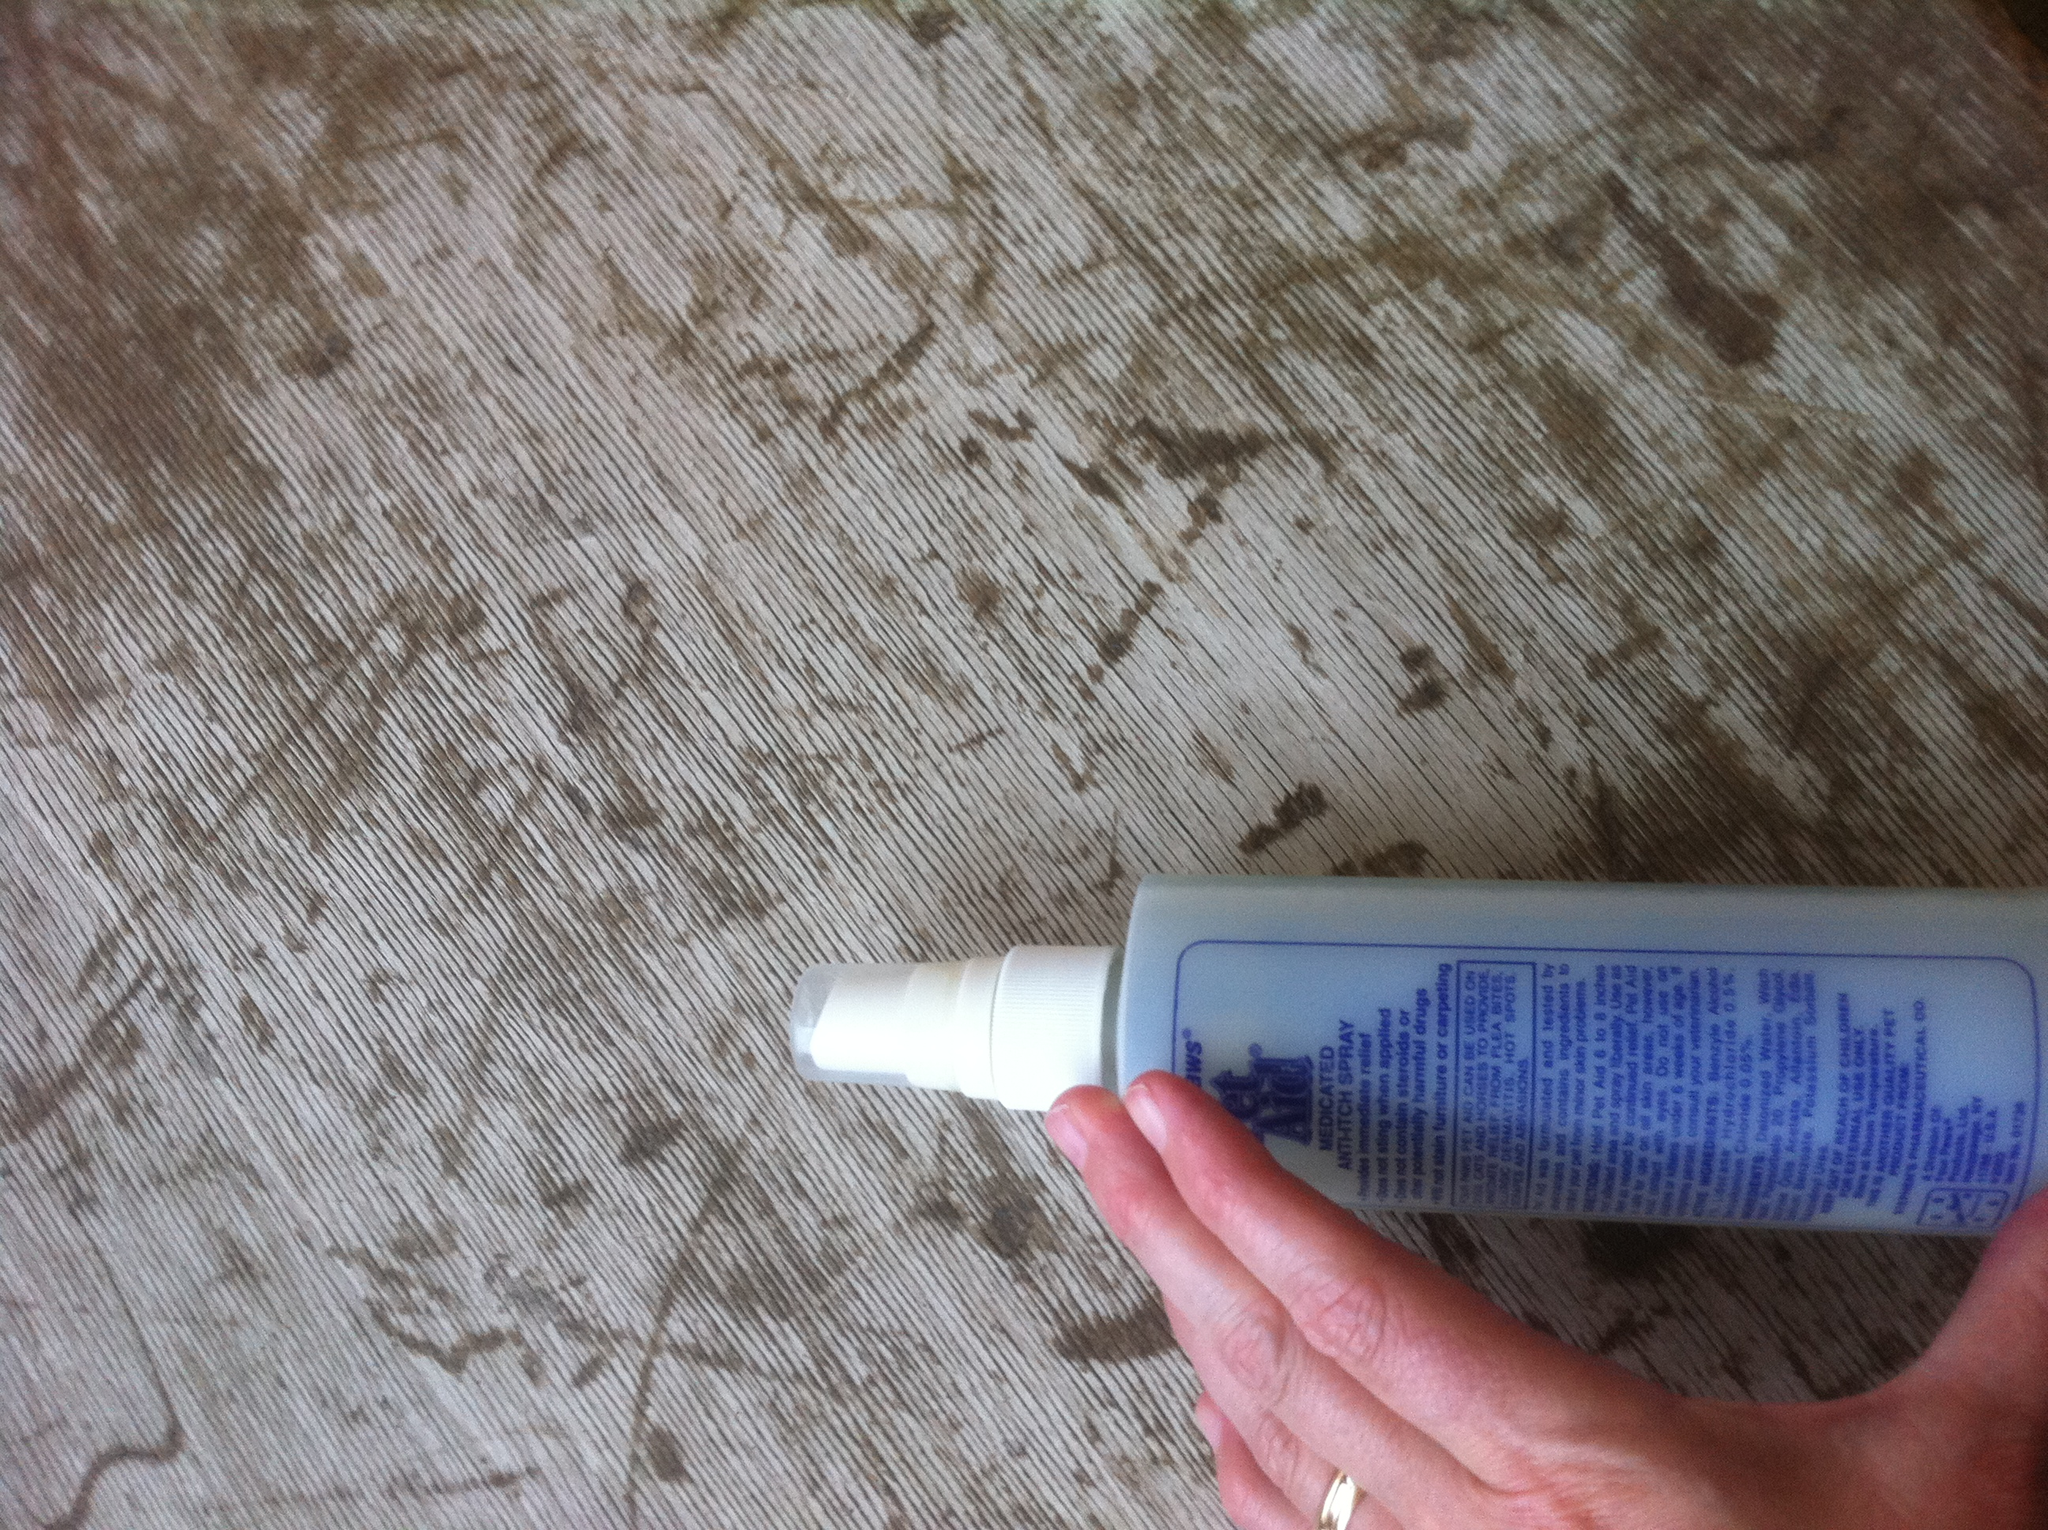Imagine this product came from a magical pet care shop. What special powers would it have? If this product were from a magical pet care shop, it might have the power to instantly heal any skin condition upon application, give the dog a shiny, radiant coat that repels dirt and water, and provide a calming aroma that instantly soothes and relaxes the pet. Additionally, it could have the ability to slightly levitate the pet playfully while being applied, making grooming an enjoyable experience for both the pet and the owner. 